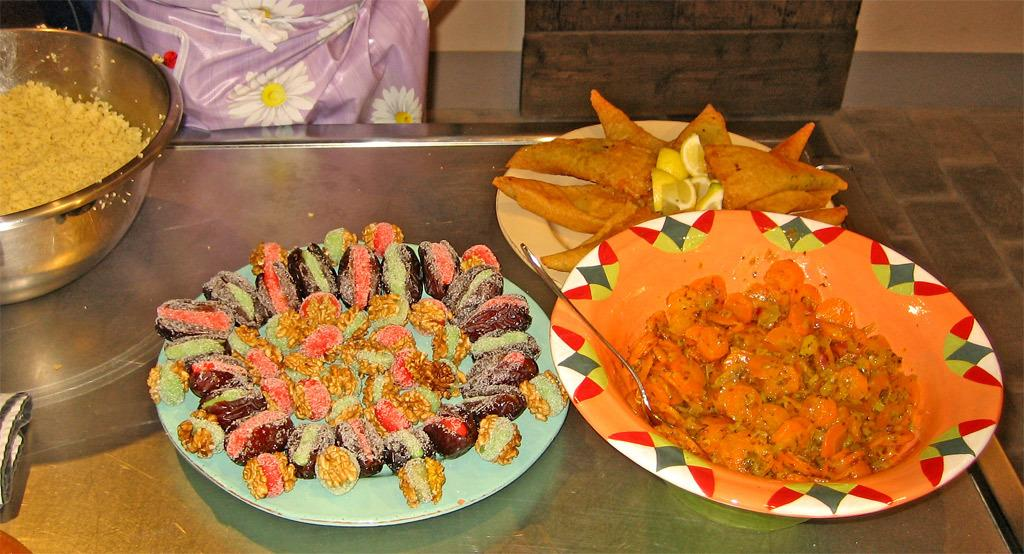How many plates and a bowl are visible in the image? There are three plates and a bowl in the image. What is on the plates and bowl? The plates and bowl contain food items. What utensil can be seen in the image? There is a spoon present in the image. What is the object on which the plates and bowl are placed? The plates and bowl are placed on an object, but the specific type of object is not mentioned in the facts. What can be seen behind the object? There is a wall visible behind the object. What thought is the insect having while swimming in the image? There is no insect or swimming activity present in the image. 